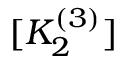<formula> <loc_0><loc_0><loc_500><loc_500>[ K _ { 2 } ^ { ( 3 ) } ]</formula> 